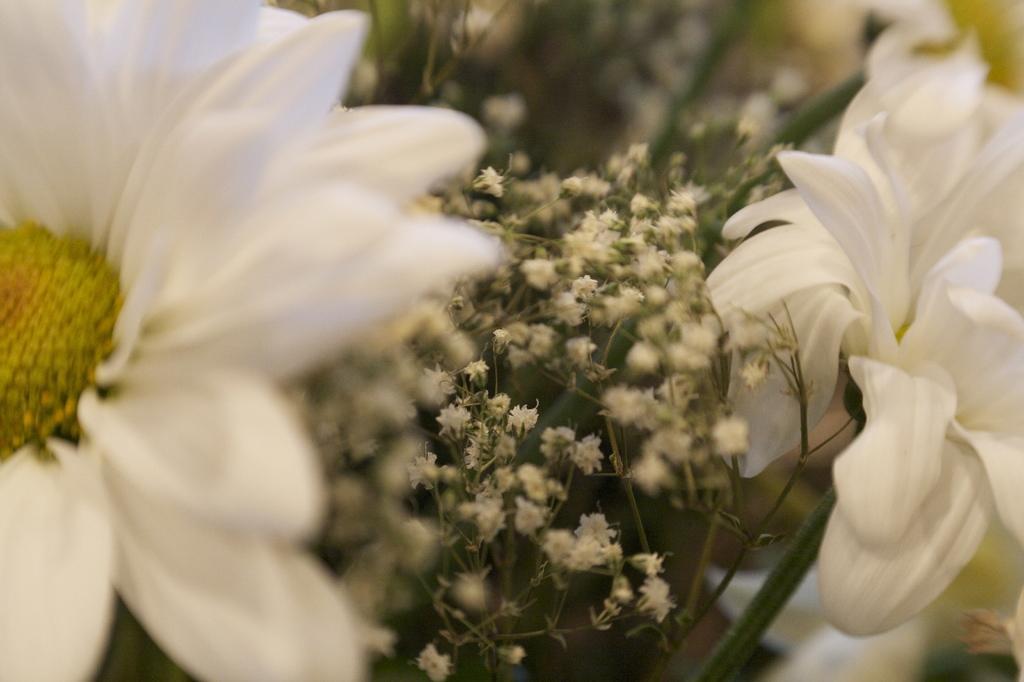How would you summarize this image in a sentence or two? This image consists of white flowers. In the middle, we can see small plants. On the left, there are pollen grains to a flower in yellow color. 